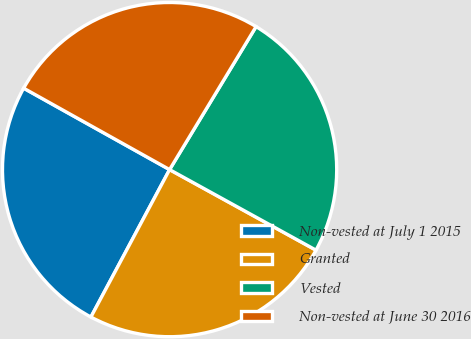Convert chart to OTSL. <chart><loc_0><loc_0><loc_500><loc_500><pie_chart><fcel>Non-vested at July 1 2015<fcel>Granted<fcel>Vested<fcel>Non-vested at June 30 2016<nl><fcel>25.3%<fcel>24.8%<fcel>24.35%<fcel>25.56%<nl></chart> 